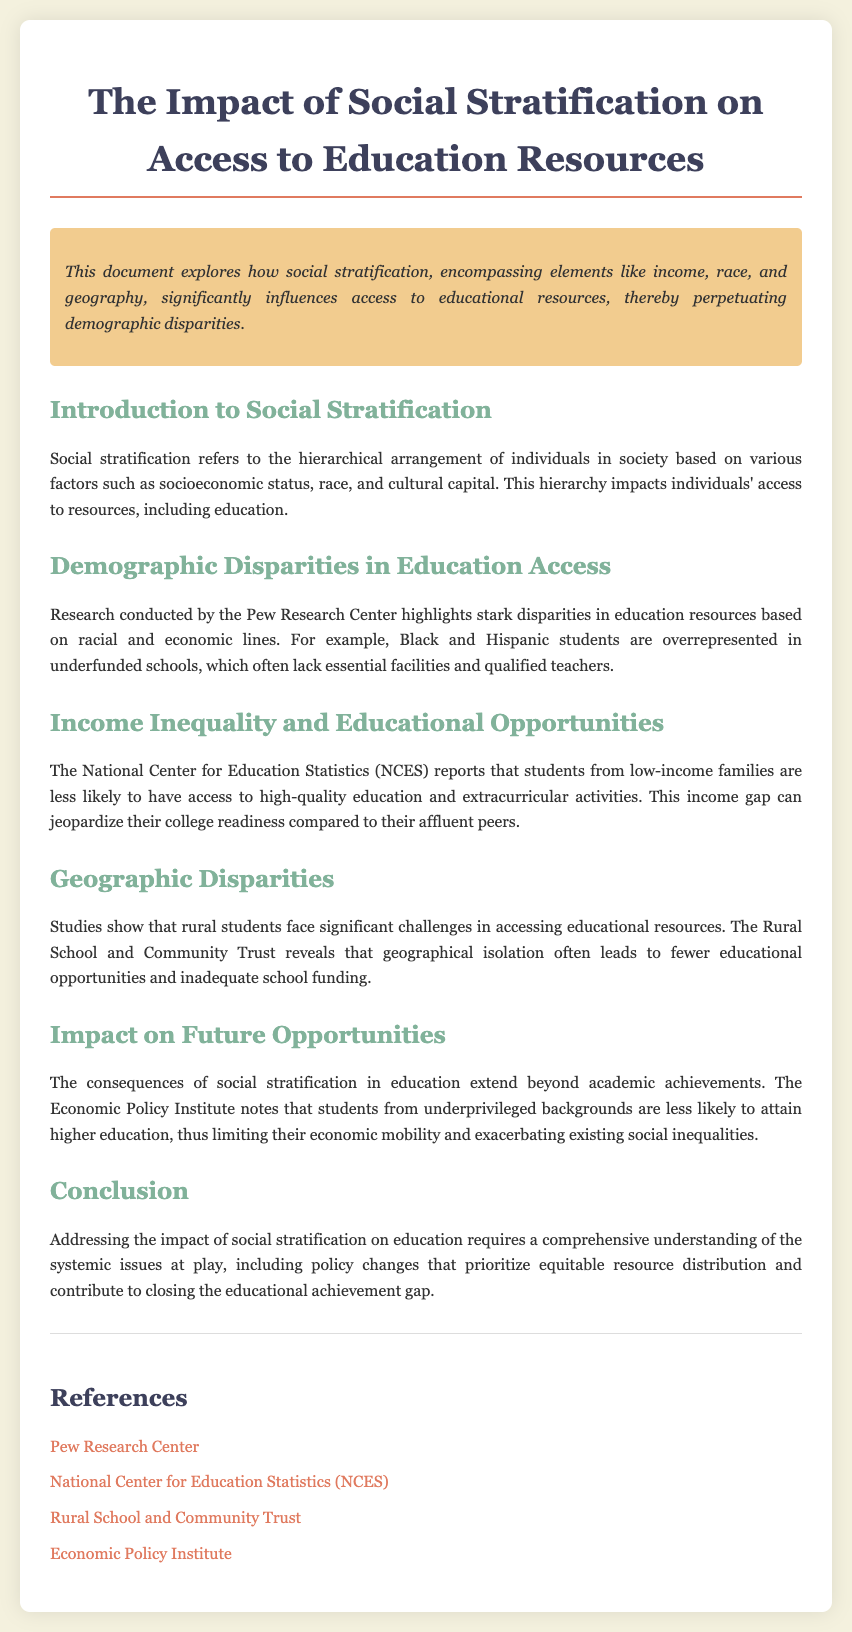What does social stratification refer to? Social stratification refers to the hierarchical arrangement of individuals in society based on various factors.
Answer: Hierarchical arrangement What demographic groups are overrepresented in underfunded schools? The document specifically mentions demographic groups that face educational disparities.
Answer: Black and Hispanic students What organization provided research on geographic disparities in education? The document states specific organizations that conducted research on education access related to geographic factors.
Answer: Rural School and Community Trust According to the NCES, what are students from low-income families less likely to access? This information pertains to findings about educational opportunities available to low-income students.
Answer: High-quality education What is one consequence of social stratification in education mentioned in the document? The document concludes with a key result of educational disparities stemming from social stratification.
Answer: Limited economic mobility What type of document is this? The format and purpose of the content can give insight into its classification.
Answer: Catalog 